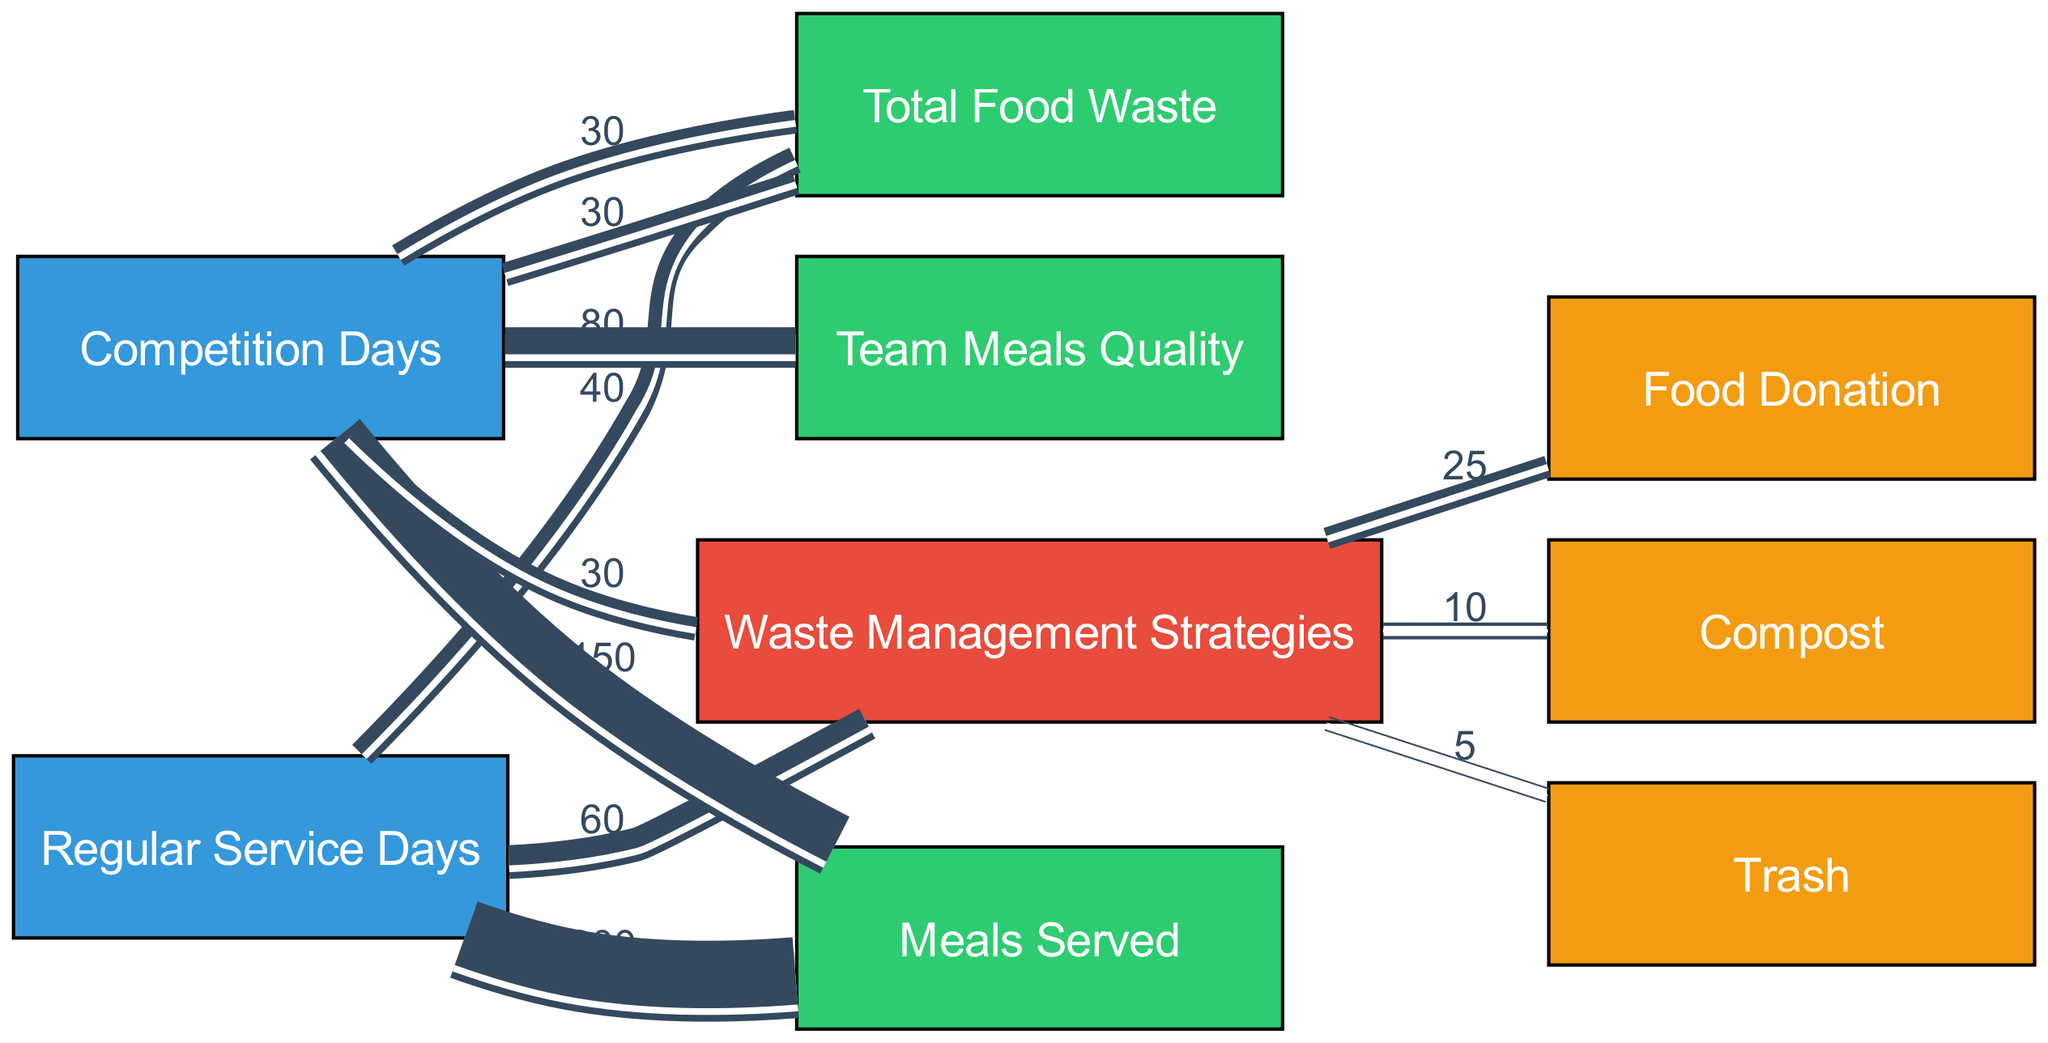What is the total food waste on regular service days? To find the total food waste on regular service days, we look for the flow from "Regular Service Days" to "Total Food Waste." The value indicated on the diagram shows 40.
Answer: 40 How many meals were served on competition days? The flow from "Competition Days" to "Meals Served" shows the number of meals served. The corresponding value is 150.
Answer: 150 What percentage of total food waste is donated on regular service days? To determine the percentage of food waste donated on regular service days, we find the food donation value (25) and divide it by the total food waste value (40), then multiply by 100. This calculation results in 62.5%.
Answer: 62.5% Which has a higher total food waste: regular service days or competition days? We compare the total food waste values for both service types. Regular service days have 40, while competition days have 30. Therefore, regular service days have higher total food waste.
Answer: Regular service days How many waste management strategies are used on competition days? Looking at the flow from "Competition Days" to "Waste Management Strategies," there is a connection indicating a management strategy total value of 30, but the specific strategies are identified separately in the links. Three strategies (Food Donation, Compost, Trash) are used.
Answer: Three What is the total meals served across both types of days? To get the total meals served, we add meals served during regular service days (200) and competition days (150). The total comes to 350.
Answer: 350 What strategy yields the least amount of waste at regular service days? In the waste management strategies for regular service days, the smallest flow is to "Trash," with a value of 5. This means trash contributes the least amount of waste.
Answer: Trash What is the total quality score of team meals on competition days? The diagram shows a direct connection from "Competition Days" to "Team Meals Quality" with a value of 80. Hence, the quality score for team meals on competition days is 80.
Answer: 80 Which waste management strategy has the highest flow from competition days? Observing the waste management strategies from "Competition Days," the strategy with the highest value is "Food Donation," which has a flow of 25.
Answer: Food Donation 